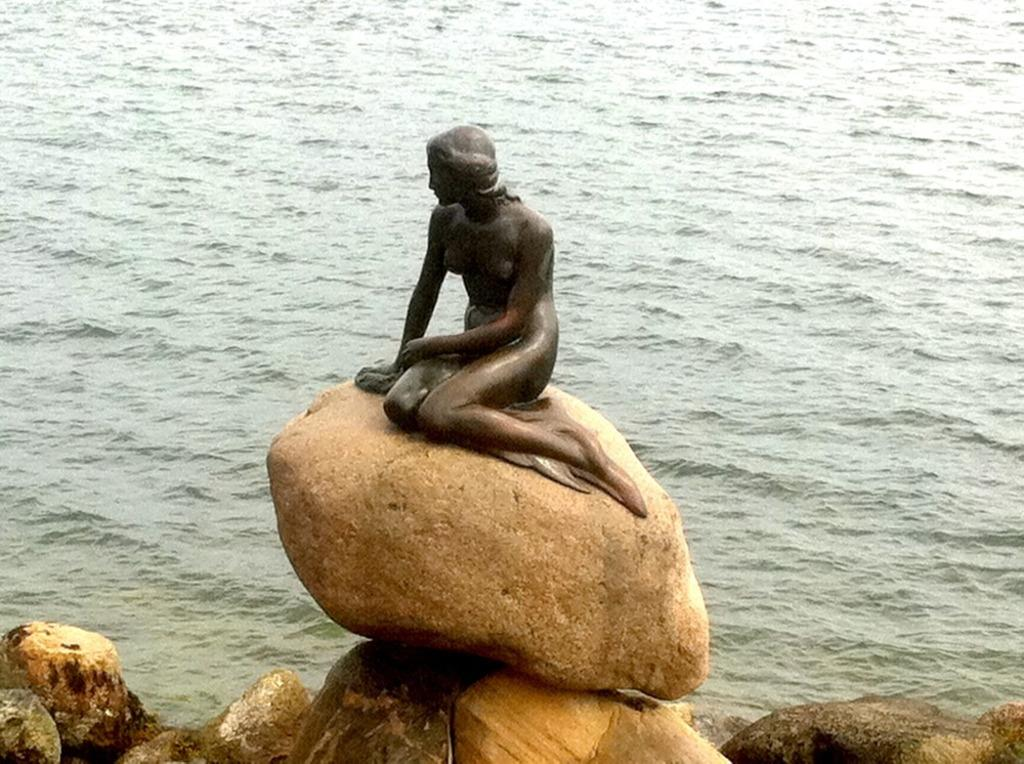What is the main subject in the image? There is a statue in the image. Where is the statue located? The statue is on rocks. What can be seen in the background of the image? There is water visible in the background of the image. What type of education does the judge in the image have? There is no judge present in the image, only a statue. What is the statue's interest in the image? The statue is a non-living object and does not have interests. 